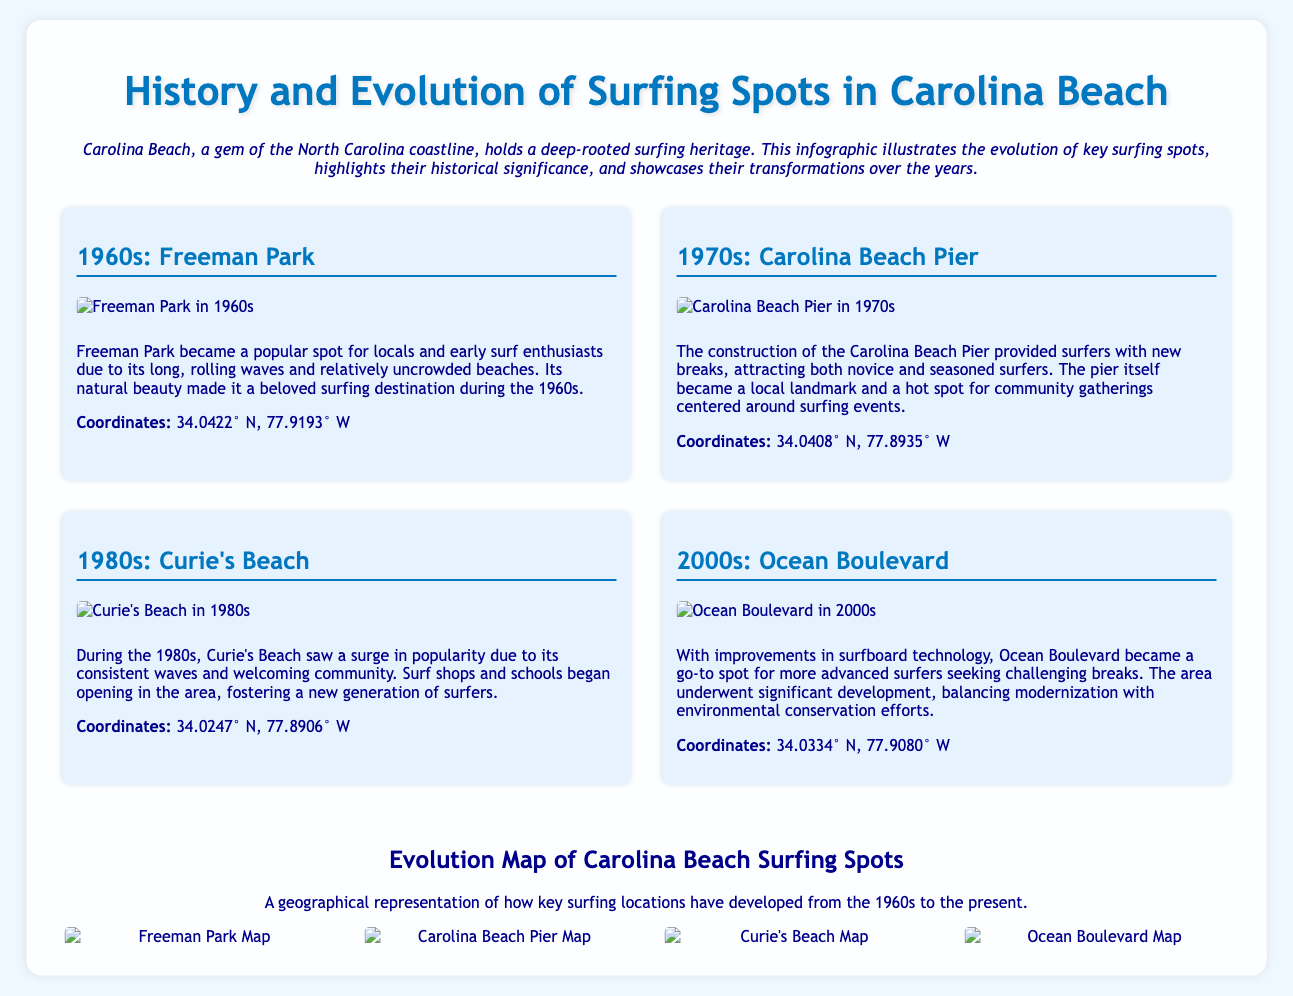What surfing spot became popular in the 1960s? The document states that Freeman Park became a popular spot for locals and early surf enthusiasts during the 1960s.
Answer: Freeman Park In which decade did Curie's Beach see a surge in popularity? The document indicates that Curie's Beach saw a surge in popularity during the 1980s due to its consistent waves and welcoming community.
Answer: 1980s What coordinates are associated with Ocean Boulevard? The coordinates listed for Ocean Boulevard in the document are 34.0334° N, 77.9080° W.
Answer: 34.0334° N, 77.9080° W How many key surfing locations are mentioned in the infographic? The document describes four key surfing locations: Freeman Park, Carolina Beach Pier, Curie's Beach, and Ocean Boulevard.
Answer: Four What notable construction in the 1970s provided new breaks for surfers? According to the document, the construction of the Carolina Beach Pier provided surfers with new breaks.
Answer: Carolina Beach Pier Which surfing spot is highlighted for its environmental conservation efforts in the 2000s? The document mentions that Ocean Boulevard underwent significant development balancing modernization with environmental conservation efforts.
Answer: Ocean Boulevard What type of image accompanies each surfing spot in the infographic? Each surfing spot in the document is accompanied by an image that visually represents the spot during its historical time frame.
Answer: Photos Which decade is associated with the establishment of surf shops and schools? The document indicates that during the 1980s, surf shops and schools began opening in the Curie's Beach area.
Answer: 1980s 